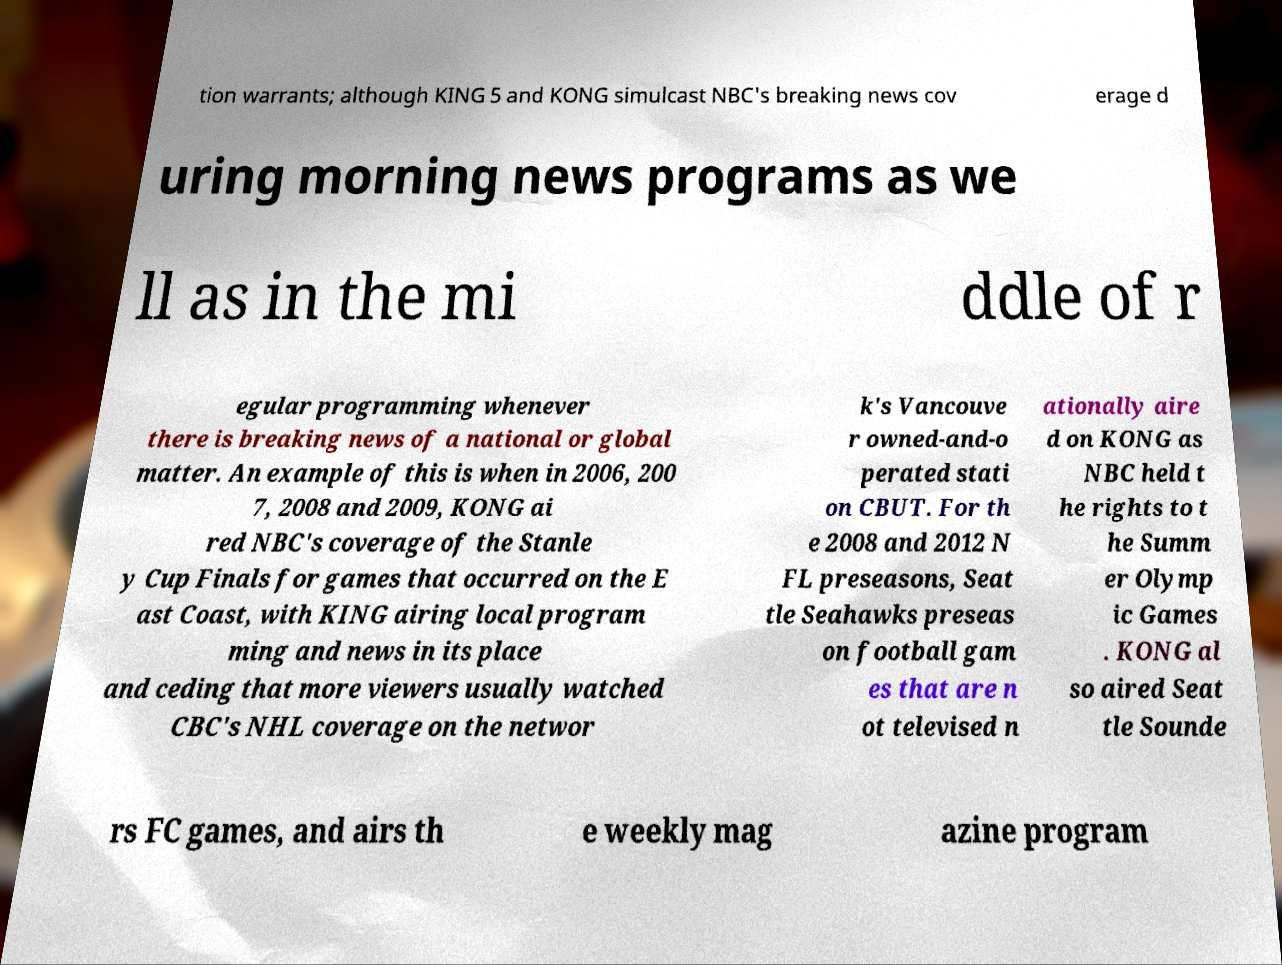Can you read and provide the text displayed in the image?This photo seems to have some interesting text. Can you extract and type it out for me? tion warrants; although KING 5 and KONG simulcast NBC's breaking news cov erage d uring morning news programs as we ll as in the mi ddle of r egular programming whenever there is breaking news of a national or global matter. An example of this is when in 2006, 200 7, 2008 and 2009, KONG ai red NBC's coverage of the Stanle y Cup Finals for games that occurred on the E ast Coast, with KING airing local program ming and news in its place and ceding that more viewers usually watched CBC's NHL coverage on the networ k's Vancouve r owned-and-o perated stati on CBUT. For th e 2008 and 2012 N FL preseasons, Seat tle Seahawks preseas on football gam es that are n ot televised n ationally aire d on KONG as NBC held t he rights to t he Summ er Olymp ic Games . KONG al so aired Seat tle Sounde rs FC games, and airs th e weekly mag azine program 